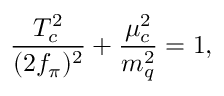Convert formula to latex. <formula><loc_0><loc_0><loc_500><loc_500>\frac { T _ { c } ^ { 2 } } { ( 2 f _ { \pi } ) ^ { 2 } } + \frac { \mu _ { c } ^ { 2 } } { m _ { q } ^ { 2 } } = 1 ,</formula> 